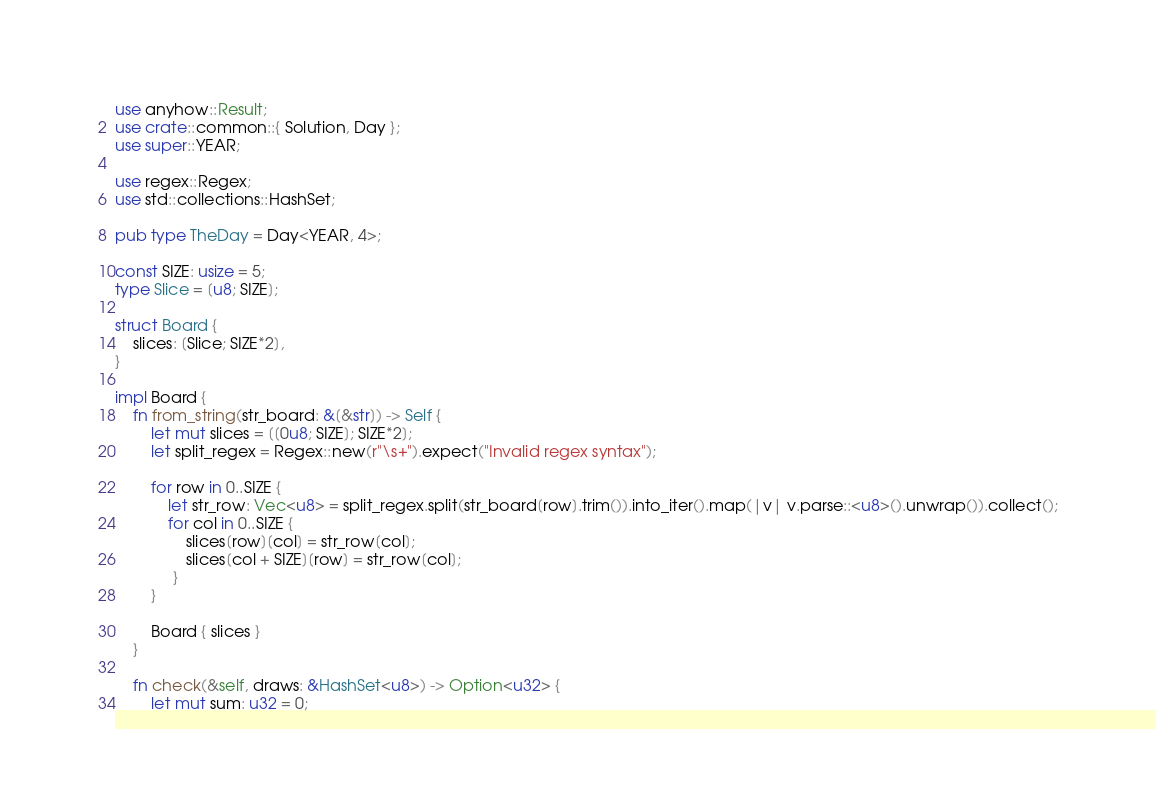Convert code to text. <code><loc_0><loc_0><loc_500><loc_500><_Rust_>use anyhow::Result;
use crate::common::{ Solution, Day };
use super::YEAR;

use regex::Regex;
use std::collections::HashSet;

pub type TheDay = Day<YEAR, 4>;

const SIZE: usize = 5;
type Slice = [u8; SIZE];

struct Board {
    slices: [Slice; SIZE*2],
}

impl Board {
    fn from_string(str_board: &[&str]) -> Self {
        let mut slices = [[0u8; SIZE]; SIZE*2];
        let split_regex = Regex::new(r"\s+").expect("Invalid regex syntax"); 

        for row in 0..SIZE {
            let str_row: Vec<u8> = split_regex.split(str_board[row].trim()).into_iter().map(|v| v.parse::<u8>().unwrap()).collect();
            for col in 0..SIZE {
                slices[row][col] = str_row[col];
                slices[col + SIZE][row] = str_row[col];
             }
        }

        Board { slices }
    }

    fn check(&self, draws: &HashSet<u8>) -> Option<u32> {
        let mut sum: u32 = 0;</code> 